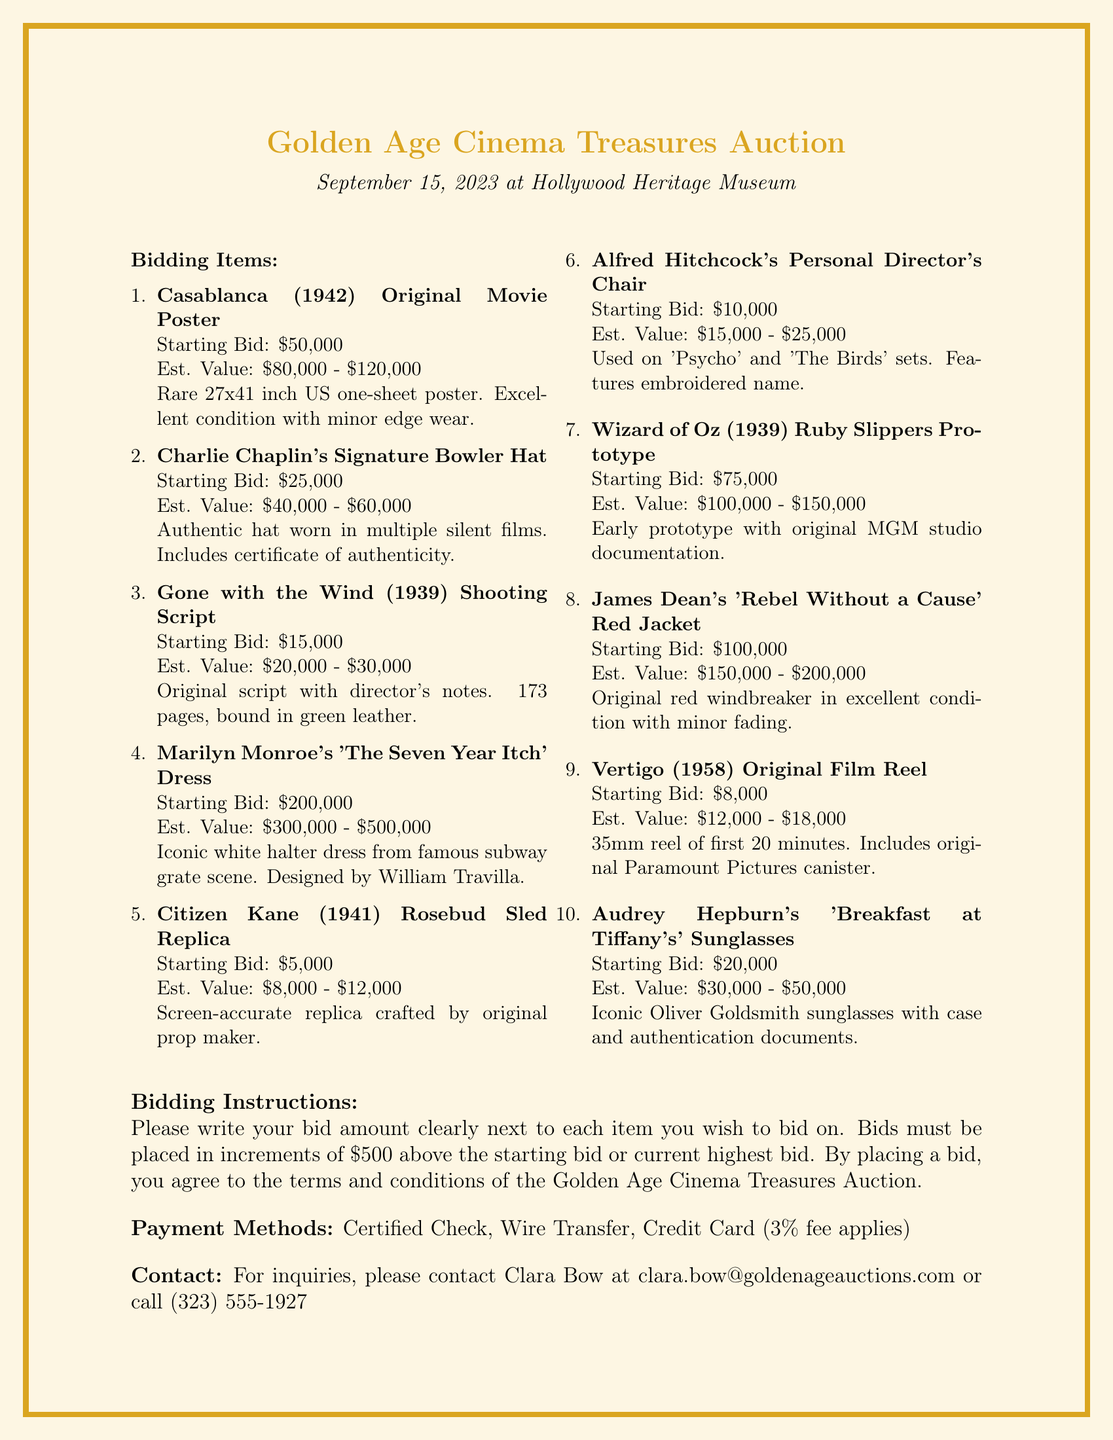What is the auction date? The auction date is explicitly stated in the document as September 15, 2023.
Answer: September 15, 2023 What is the starting bid for the Ruby Slippers Prototype? The starting bid for the Ruby Slippers Prototype can be found in the item description, which lists it as $75,000.
Answer: $75,000 Who should inquiries be directed to? The document provides a contact person for inquiries, which is Clara Bow.
Answer: Clara Bow What is the estimated value range for Marilyn Monroe's dress? The estimated value range for Marilyn Monroe's dress is specified in the document as $300,000 - $500,000.
Answer: $300,000 - $500,000 How many pages is the Gone with the Wind script? The page count of the Gone with the Wind script is mentioned as 173 pages in the document.
Answer: 173 pages What payment methods are accepted? The document lists accepted payment methods, which include Certified Check, Wire Transfer, and Credit Card.
Answer: Certified Check, Wire Transfer, Credit Card What item number corresponds to James Dean's red jacket? The item number for James Dean's red jacket is provided in the document as 008.
Answer: 008 What condition is the Casablanca poster described in? The document states that the condition of the Casablanca poster is excellent with minor edge wear.
Answer: Excellent condition with minor edge wear 